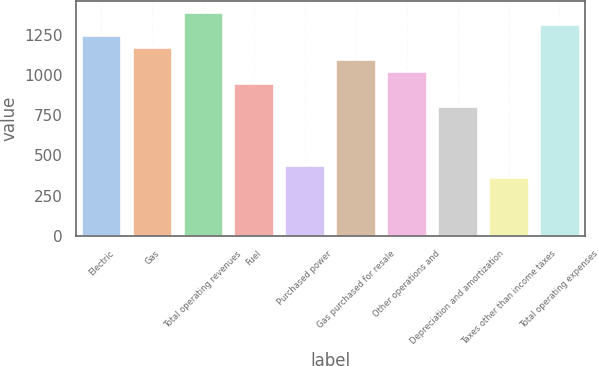<chart> <loc_0><loc_0><loc_500><loc_500><bar_chart><fcel>Electric<fcel>Gas<fcel>Total operating revenues<fcel>Fuel<fcel>Purchased power<fcel>Gas purchased for resale<fcel>Other operations and<fcel>Depreciation and amortization<fcel>Taxes other than income taxes<fcel>Total operating expenses<nl><fcel>1244.7<fcel>1171.6<fcel>1390.9<fcel>952.3<fcel>440.6<fcel>1098.5<fcel>1025.4<fcel>806.1<fcel>367.5<fcel>1317.8<nl></chart> 